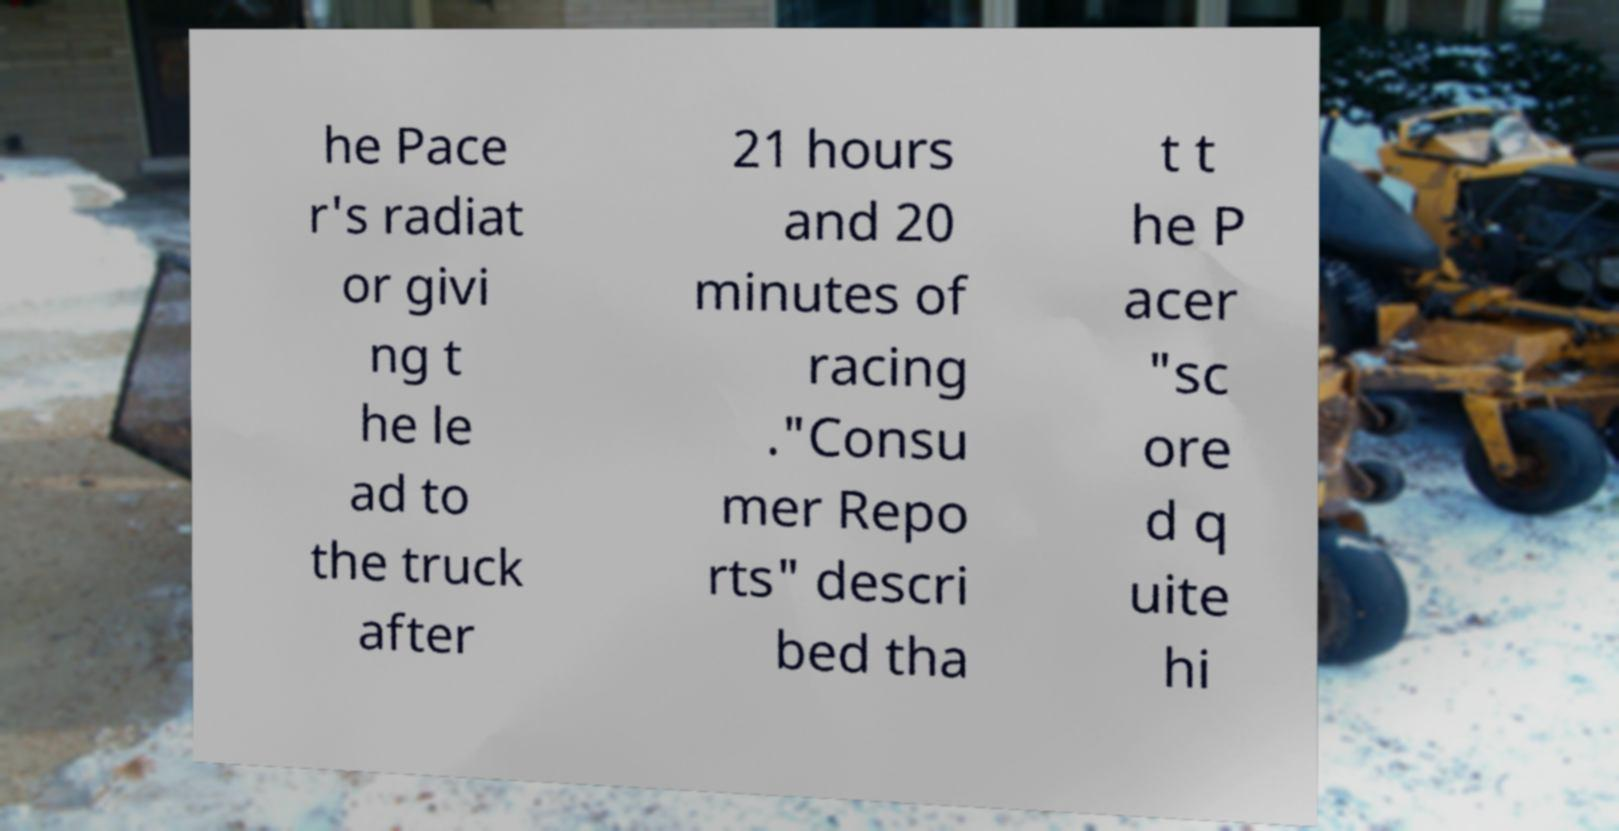For documentation purposes, I need the text within this image transcribed. Could you provide that? he Pace r's radiat or givi ng t he le ad to the truck after 21 hours and 20 minutes of racing ."Consu mer Repo rts" descri bed tha t t he P acer "sc ore d q uite hi 